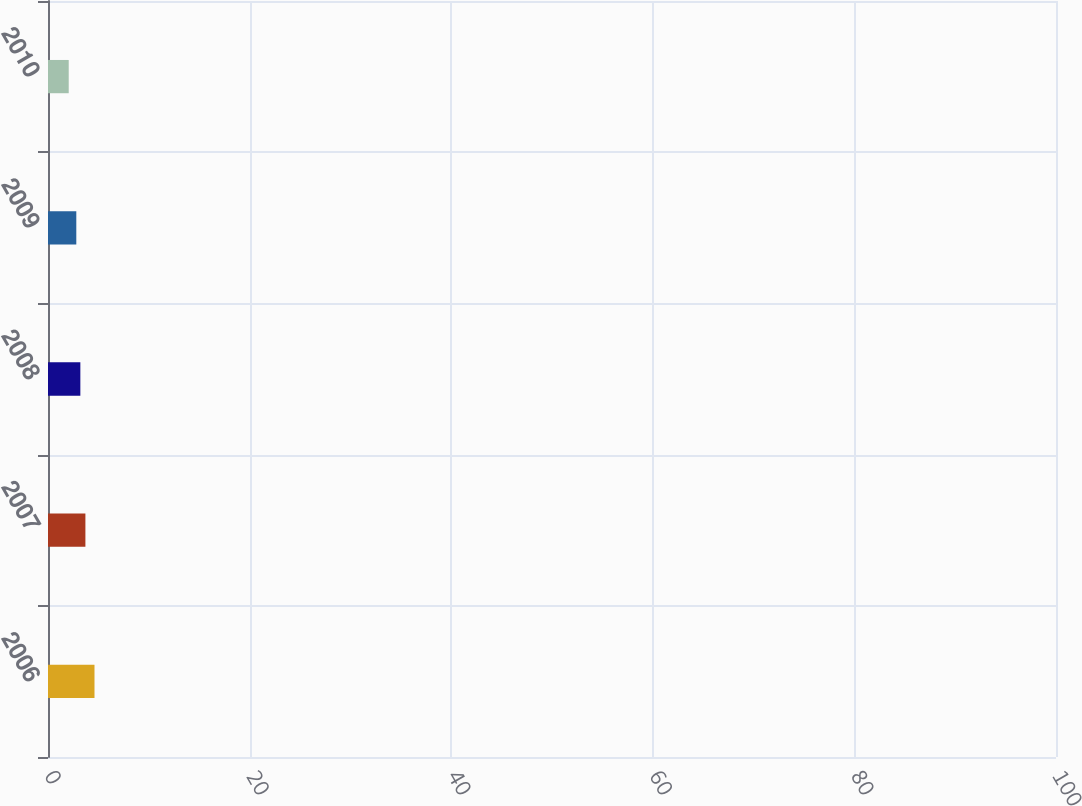Convert chart. <chart><loc_0><loc_0><loc_500><loc_500><bar_chart><fcel>2006<fcel>2007<fcel>2008<fcel>2009<fcel>2010<nl><fcel>92<fcel>74<fcel>64<fcel>56<fcel>41<nl></chart> 